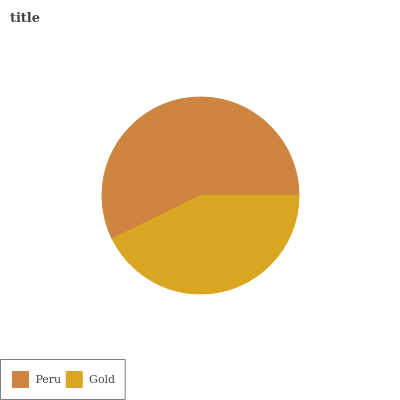Is Gold the minimum?
Answer yes or no. Yes. Is Peru the maximum?
Answer yes or no. Yes. Is Gold the maximum?
Answer yes or no. No. Is Peru greater than Gold?
Answer yes or no. Yes. Is Gold less than Peru?
Answer yes or no. Yes. Is Gold greater than Peru?
Answer yes or no. No. Is Peru less than Gold?
Answer yes or no. No. Is Peru the high median?
Answer yes or no. Yes. Is Gold the low median?
Answer yes or no. Yes. Is Gold the high median?
Answer yes or no. No. Is Peru the low median?
Answer yes or no. No. 